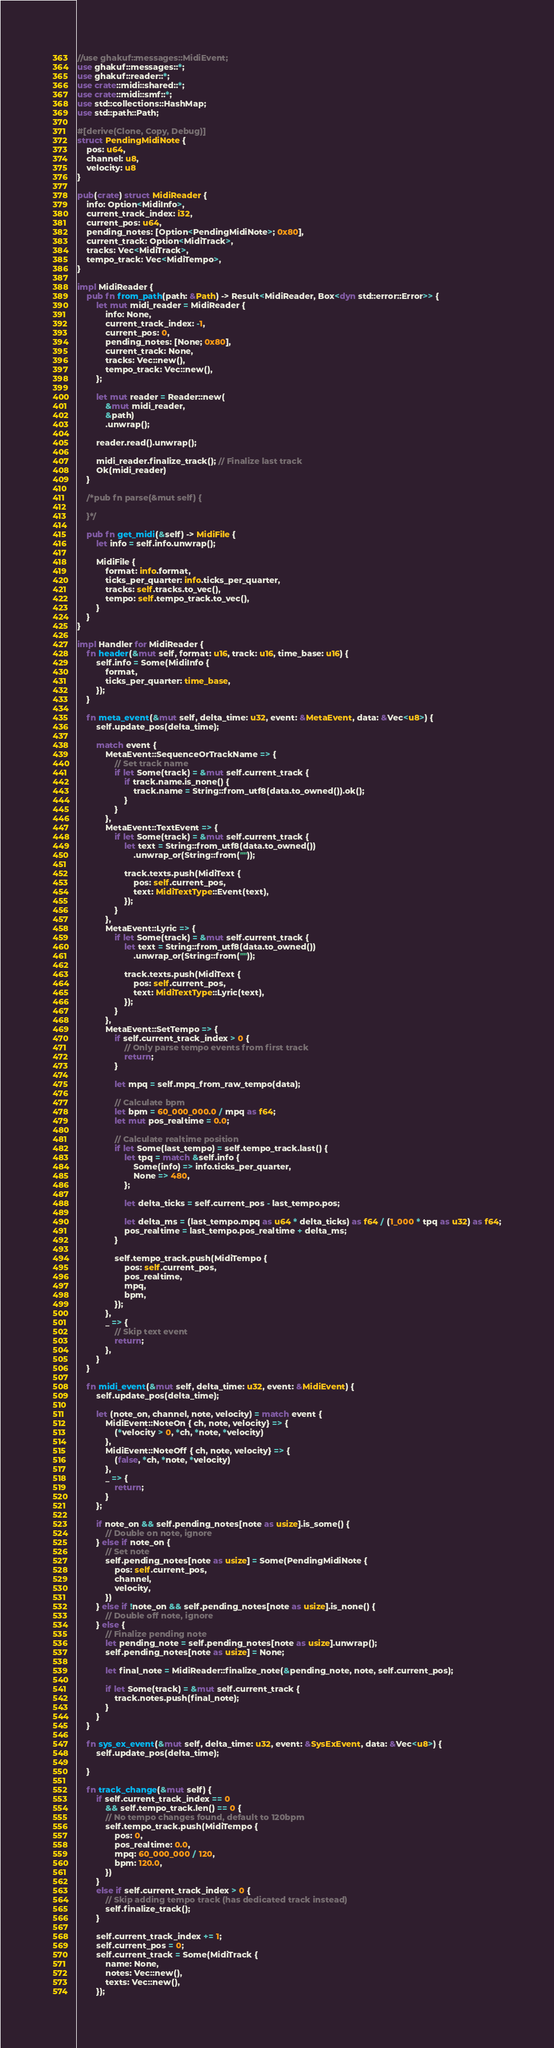Convert code to text. <code><loc_0><loc_0><loc_500><loc_500><_Rust_>//use ghakuf::messages::MidiEvent;
use ghakuf::messages::*;
use ghakuf::reader::*;
use crate::midi::shared::*;
use crate::midi::smf::*;
use std::collections::HashMap;
use std::path::Path;

#[derive(Clone, Copy, Debug)]
struct PendingMidiNote {
    pos: u64,
    channel: u8,
    velocity: u8
}

pub(crate) struct MidiReader {
    info: Option<MidiInfo>,
    current_track_index: i32,
    current_pos: u64,
    pending_notes: [Option<PendingMidiNote>; 0x80],
    current_track: Option<MidiTrack>,
    tracks: Vec<MidiTrack>,
    tempo_track: Vec<MidiTempo>,
}

impl MidiReader {
    pub fn from_path(path: &Path) -> Result<MidiReader, Box<dyn std::error::Error>> {
        let mut midi_reader = MidiReader {
            info: None,
            current_track_index: -1,
            current_pos: 0,
            pending_notes: [None; 0x80],
            current_track: None,
            tracks: Vec::new(),
            tempo_track: Vec::new(),
        };

        let mut reader = Reader::new(
            &mut midi_reader,
            &path)
            .unwrap();
        
        reader.read().unwrap();

        midi_reader.finalize_track(); // Finalize last track
        Ok(midi_reader)
    }

    /*pub fn parse(&mut self) {

    }*/

    pub fn get_midi(&self) -> MidiFile {
        let info = self.info.unwrap();

        MidiFile {
            format: info.format,
            ticks_per_quarter: info.ticks_per_quarter,
            tracks: self.tracks.to_vec(),
            tempo: self.tempo_track.to_vec(),
        }
    }
}

impl Handler for MidiReader {
    fn header(&mut self, format: u16, track: u16, time_base: u16) {
        self.info = Some(MidiInfo {
            format,
            ticks_per_quarter: time_base,
        });
    }

    fn meta_event(&mut self, delta_time: u32, event: &MetaEvent, data: &Vec<u8>) {
        self.update_pos(delta_time);

        match event {
            MetaEvent::SequenceOrTrackName => {
                // Set track name
                if let Some(track) = &mut self.current_track {
                    if track.name.is_none() {
                        track.name = String::from_utf8(data.to_owned()).ok();
                    }
                }
            },
            MetaEvent::TextEvent => {                
                if let Some(track) = &mut self.current_track {
                    let text = String::from_utf8(data.to_owned())
                        .unwrap_or(String::from(""));

                    track.texts.push(MidiText {
                        pos: self.current_pos,
                        text: MidiTextType::Event(text),
                    });
                }
            },
            MetaEvent::Lyric => {                
                if let Some(track) = &mut self.current_track {
                    let text = String::from_utf8(data.to_owned())
                        .unwrap_or(String::from(""));

                    track.texts.push(MidiText {
                        pos: self.current_pos,
                        text: MidiTextType::Lyric(text),
                    });
                }
            },
            MetaEvent::SetTempo => {
                if self.current_track_index > 0 {
                    // Only parse tempo events from first track
                    return;
                }

                let mpq = self.mpq_from_raw_tempo(data);

                // Calculate bpm
                let bpm = 60_000_000.0 / mpq as f64;
                let mut pos_realtime = 0.0;

                // Calculate realtime position
                if let Some(last_tempo) = self.tempo_track.last() {
                    let tpq = match &self.info {
                        Some(info) => info.ticks_per_quarter,
                        None => 480,
                    };

                    let delta_ticks = self.current_pos - last_tempo.pos;
                    
                    let delta_ms = (last_tempo.mpq as u64 * delta_ticks) as f64 / (1_000 * tpq as u32) as f64;
                    pos_realtime = last_tempo.pos_realtime + delta_ms;
                }

                self.tempo_track.push(MidiTempo {
                    pos: self.current_pos,
                    pos_realtime,
                    mpq,
                    bpm,
                });
            },
            _ => {
                // Skip text event
                return;
            },
        }
    }

    fn midi_event(&mut self, delta_time: u32, event: &MidiEvent) {
        self.update_pos(delta_time);

        let (note_on, channel, note, velocity) = match event {
            MidiEvent::NoteOn { ch, note, velocity} => {
                (*velocity > 0, *ch, *note, *velocity)
            },
            MidiEvent::NoteOff { ch, note, velocity} => {
                (false, *ch, *note, *velocity)
            },
            _ => {
                return;
            }
        };

        if note_on && self.pending_notes[note as usize].is_some() {
            // Double on note, ignore
        } else if note_on {
            // Set note
            self.pending_notes[note as usize] = Some(PendingMidiNote {
                pos: self.current_pos,
                channel,
                velocity,
            })
        } else if !note_on && self.pending_notes[note as usize].is_none() {
            // Double off note, ignore
        } else {
            // Finalize pending note
            let pending_note = self.pending_notes[note as usize].unwrap();
            self.pending_notes[note as usize] = None;

            let final_note = MidiReader::finalize_note(&pending_note, note, self.current_pos);

            if let Some(track) = &mut self.current_track {
                track.notes.push(final_note);
            }
        }
    }

    fn sys_ex_event(&mut self, delta_time: u32, event: &SysExEvent, data: &Vec<u8>) {
        self.update_pos(delta_time);

    }

    fn track_change(&mut self) {
        if self.current_track_index == 0
            && self.tempo_track.len() == 0 {
            // No tempo changes found, default to 120bpm
            self.tempo_track.push(MidiTempo {
                pos: 0,
                pos_realtime: 0.0,
                mpq: 60_000_000 / 120,
                bpm: 120.0,
            })
        }
        else if self.current_track_index > 0 {
            // Skip adding tempo track (has dedicated track instead)
            self.finalize_track();
        }

        self.current_track_index += 1;
        self.current_pos = 0;
        self.current_track = Some(MidiTrack {
            name: None,
            notes: Vec::new(),
            texts: Vec::new(),
        });</code> 